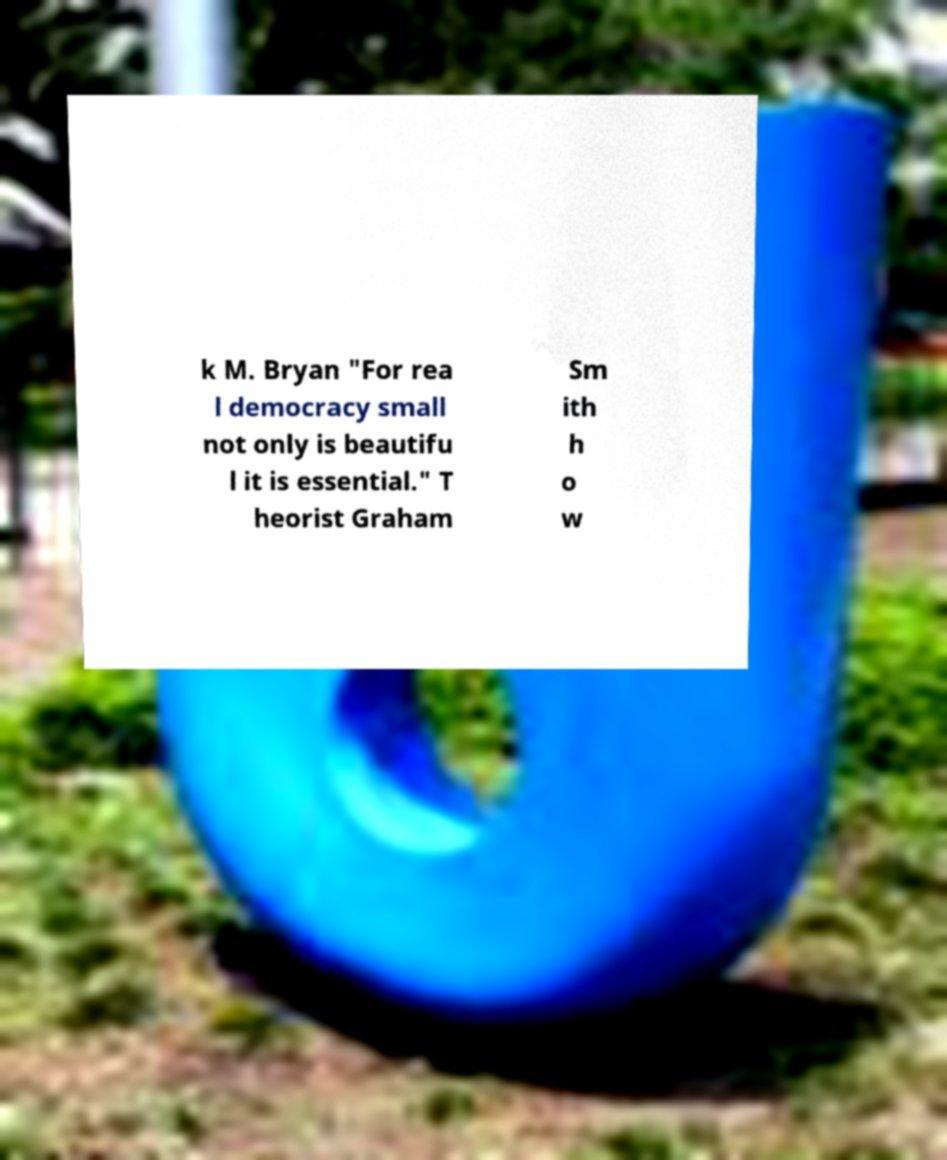Could you extract and type out the text from this image? k M. Bryan "For rea l democracy small not only is beautifu l it is essential." T heorist Graham Sm ith h o w 